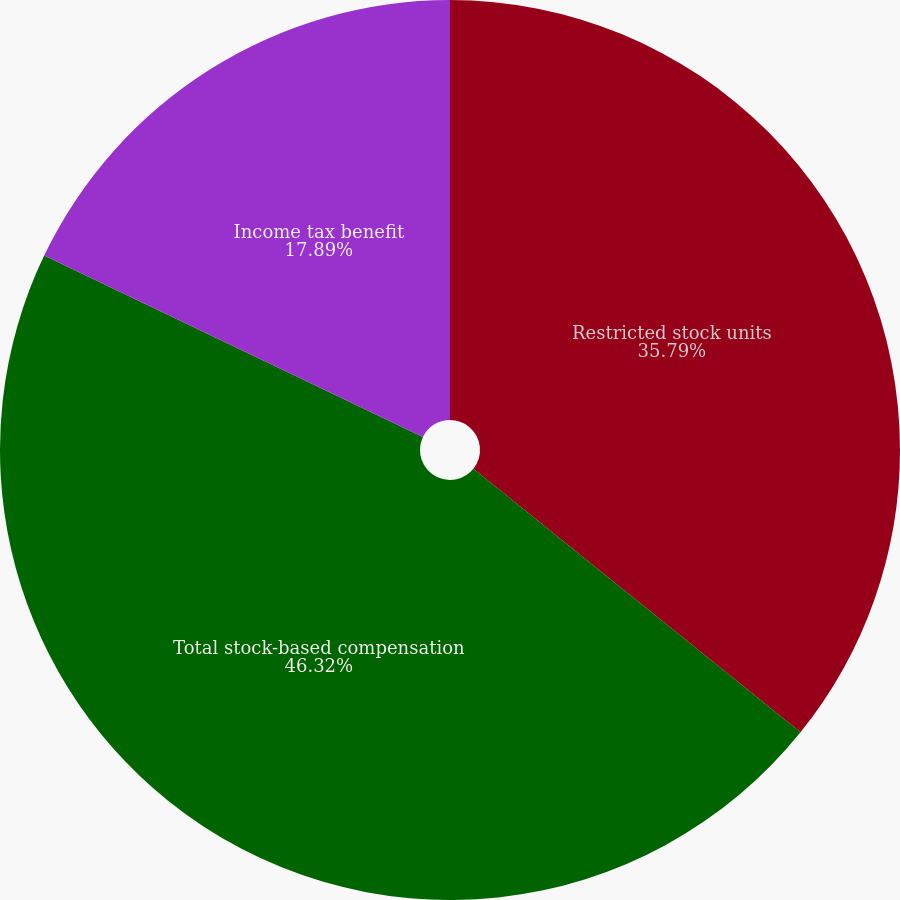Convert chart to OTSL. <chart><loc_0><loc_0><loc_500><loc_500><pie_chart><fcel>Restricted stock units<fcel>Total stock-based compensation<fcel>Income tax benefit<nl><fcel>35.79%<fcel>46.32%<fcel>17.89%<nl></chart> 